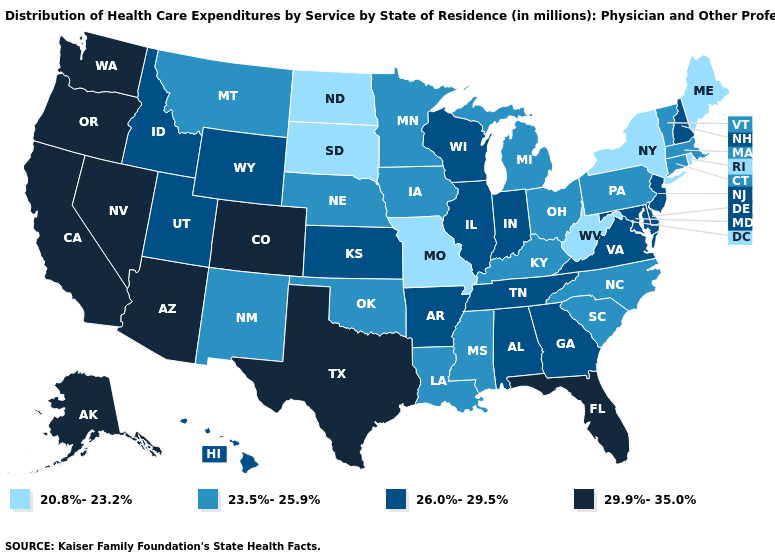What is the lowest value in the West?
Be succinct. 23.5%-25.9%. Does the first symbol in the legend represent the smallest category?
Quick response, please. Yes. What is the value of Oklahoma?
Give a very brief answer. 23.5%-25.9%. Among the states that border Florida , which have the lowest value?
Be succinct. Alabama, Georgia. What is the value of Idaho?
Write a very short answer. 26.0%-29.5%. Name the states that have a value in the range 29.9%-35.0%?
Short answer required. Alaska, Arizona, California, Colorado, Florida, Nevada, Oregon, Texas, Washington. What is the value of Rhode Island?
Short answer required. 20.8%-23.2%. Does Maryland have the lowest value in the USA?
Quick response, please. No. Among the states that border Ohio , which have the highest value?
Short answer required. Indiana. Does Virginia have the same value as Nebraska?
Write a very short answer. No. Name the states that have a value in the range 29.9%-35.0%?
Keep it brief. Alaska, Arizona, California, Colorado, Florida, Nevada, Oregon, Texas, Washington. What is the value of Hawaii?
Quick response, please. 26.0%-29.5%. What is the value of Michigan?
Concise answer only. 23.5%-25.9%. Name the states that have a value in the range 23.5%-25.9%?
Answer briefly. Connecticut, Iowa, Kentucky, Louisiana, Massachusetts, Michigan, Minnesota, Mississippi, Montana, Nebraska, New Mexico, North Carolina, Ohio, Oklahoma, Pennsylvania, South Carolina, Vermont. Does North Dakota have a higher value than Louisiana?
Be succinct. No. 